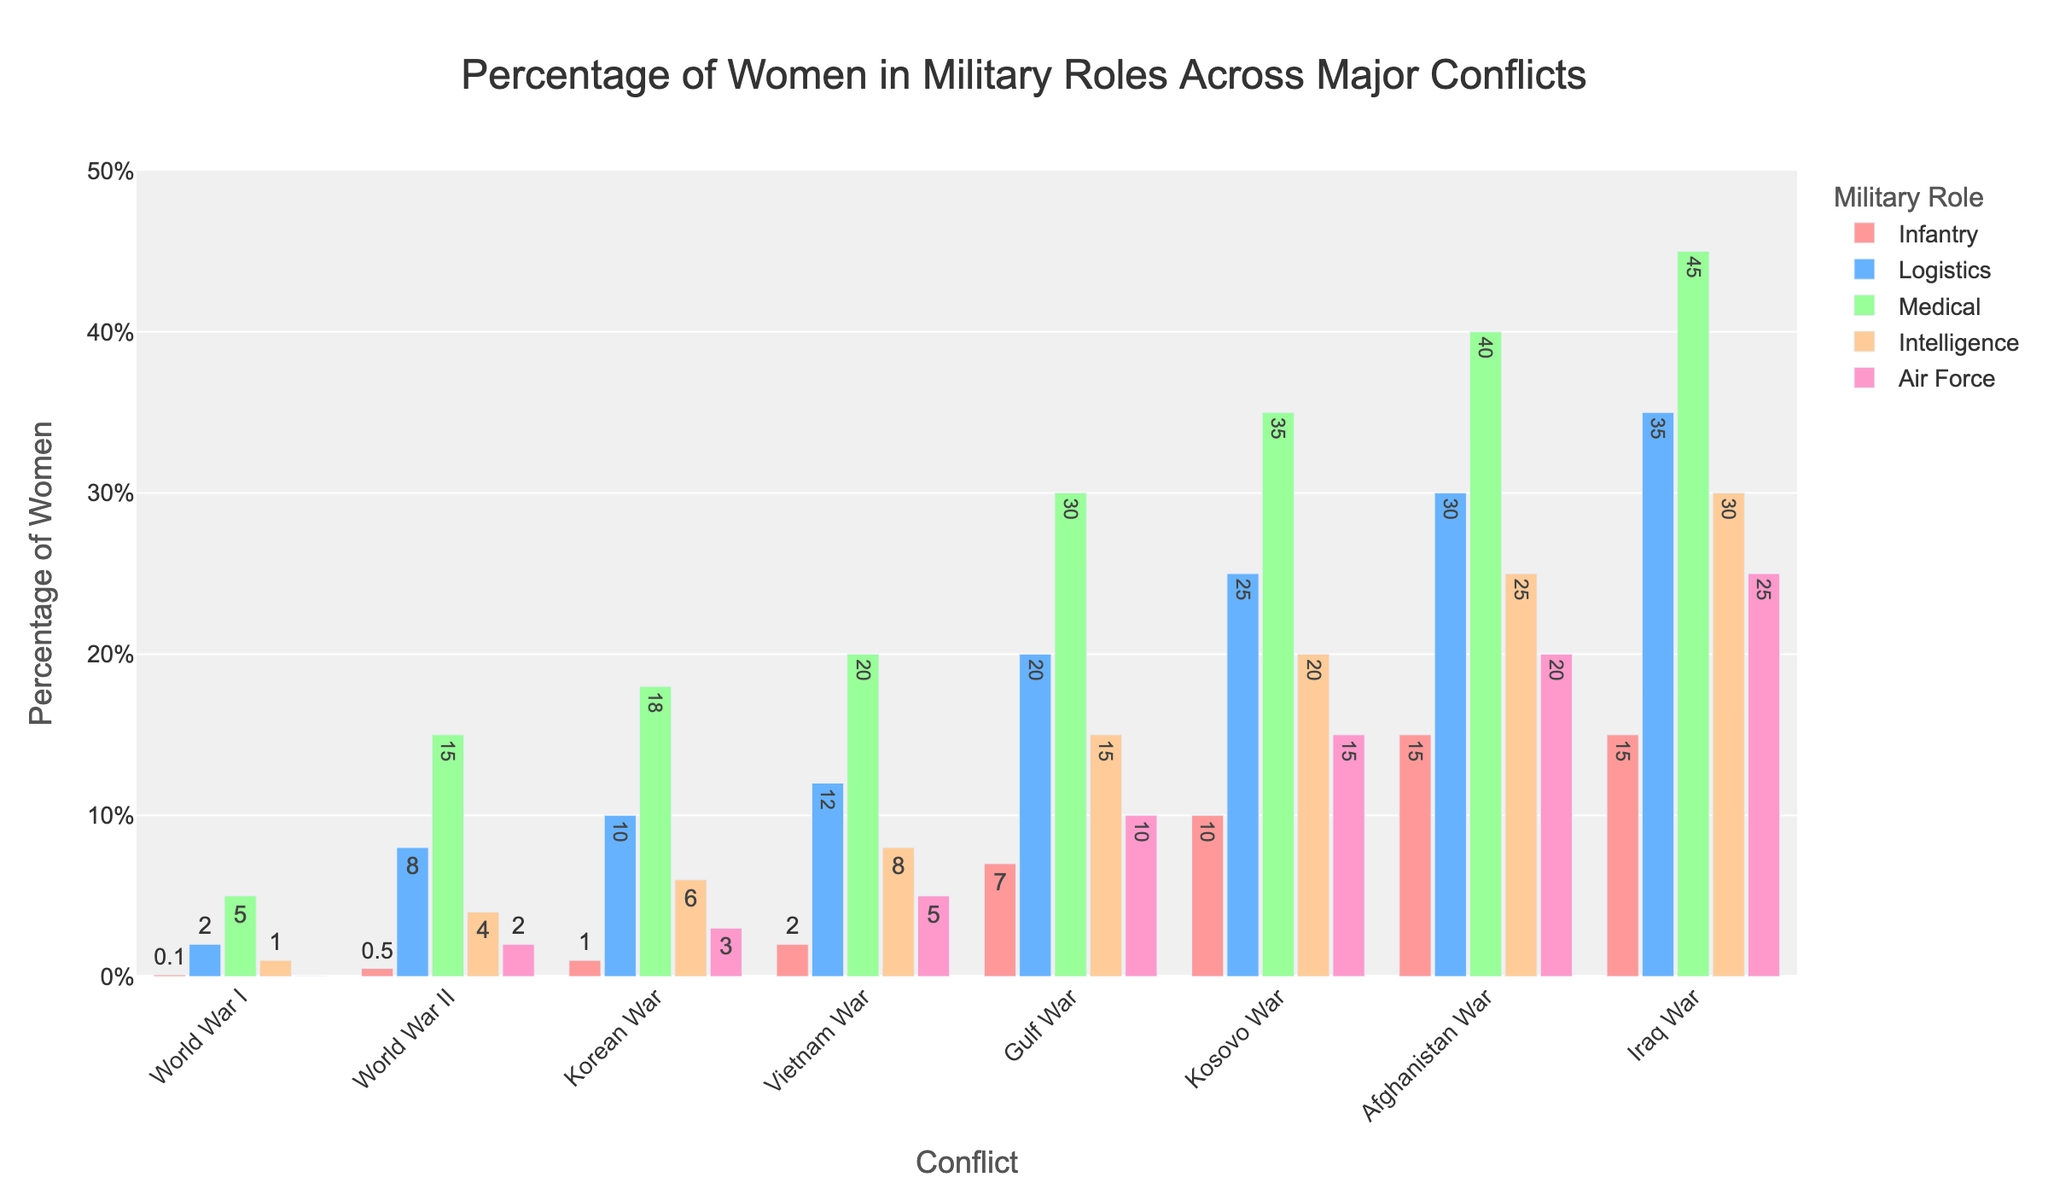What's the percentage of women in the Infantry role during the Gulf War? The bar representing the Infantry role during the Gulf War has a height indicating 7%. This can be read directly from the figure.
Answer: 7% Which conflict had the highest percentage of women in the Medical role? The height of the bars representing the Medical role increases across conflicts, with the Iraq War bar being the tallest for this role at 45%.
Answer: Iraq War What's the difference in the percentage of women in Logistics roles between World War II and Vietnam War? In World War II, the Logistics role bar shows 8%, and in Vietnam War, it shows 12%. Subtracting these two values (12% - 8%) gives the difference.
Answer: 4% How does the percentage of women in the Intelligence role in the Korean War compare to the Kosovo War? The bar for the Intelligence role in the Korean War is at 6%, while the bar for the Kosovo War is at 20%. Comparing these, we see 6% < 20%.
Answer: Lower in the Korean War by 14% What is the average percentage of women in the Air Force role across all conflicts? Sum the percentages represented by the bars for the Air Force role across all conflicts (0+2+3+5+10+15+20+25 = 80), then divide by the number of conflicts (8). Thus, 80 / 8 = 10%.
Answer: 10% Which role shows the largest percentage increase from World War I to the Gulf War? Compare the differences for each role from World War I to Gulf War:
Infantry (7-0.1)=6.9, Logistics (20-2)=18, Medical (30-5)=25, Intelligence (15-1)=14, Air Force (10-0)=10. The largest is the Medical role.
Answer: Medical In which conflict was the percentage of women in the Infantry role equal to or exceeding 10%? The bar for Infantry reaches or exceeds 10% during the Kosovo, Afghanistan, and Iraq wars.
Answer: Kosovo War, Afghanistan War, Iraq War From which conflict onwards did the percentage of women in any military role reach at least 20%? Looking at the bars across conflicts, during the Gulf War, the Logistics role reaches 20%.
Answer: Gulf War How many conflicts show at least one role where the percentage of women reaches 30% or more? Inspecting the bars, the percentages of women reach 30% or more in Logistics, Medical, Intelligence, and Air Force in the Gulf War, Kosovo War, Afghanistan War, and Iraq War.
Answer: 4 